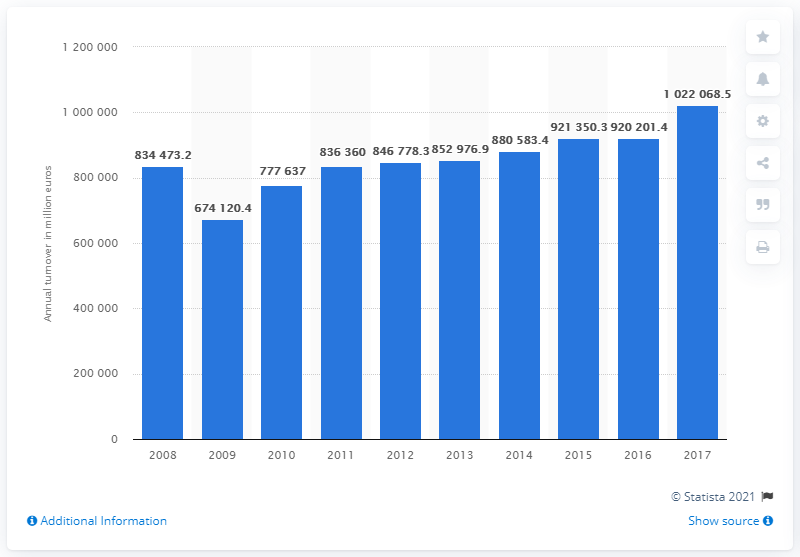List a handful of essential elements in this visual. In 2017, the total business economy turnover in Poland was 10,220,685.5. In the year 2008, the total business economy produced a turnover of approximately 1.02 trillion euros. 